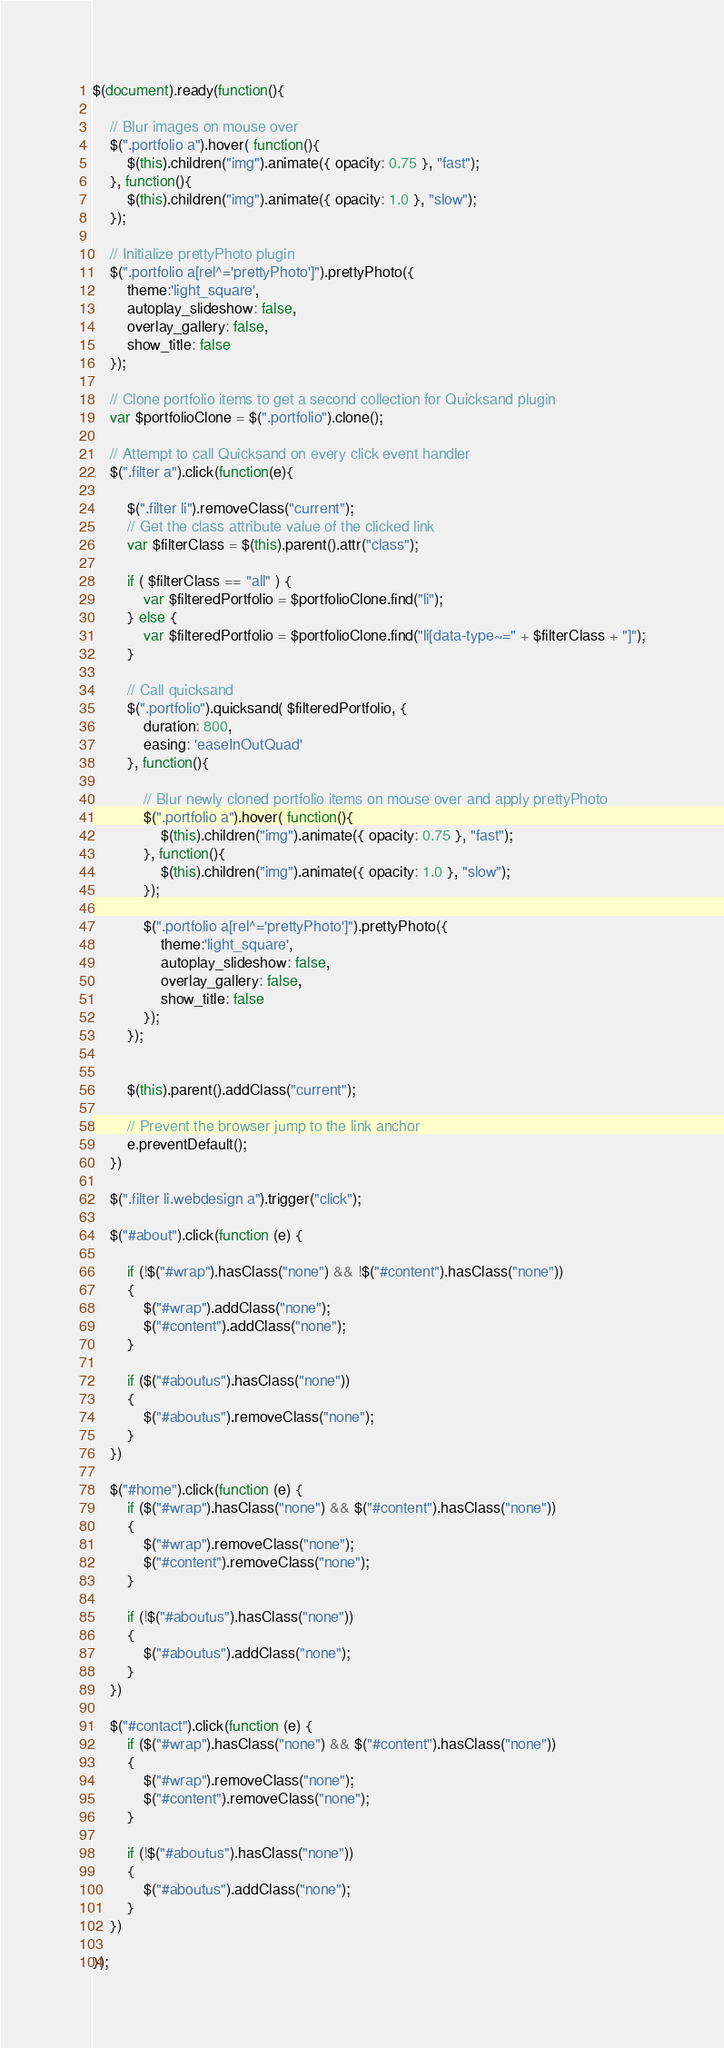<code> <loc_0><loc_0><loc_500><loc_500><_JavaScript_>$(document).ready(function(){

	// Blur images on mouse over
	$(".portfolio a").hover( function(){ 
		$(this).children("img").animate({ opacity: 0.75 }, "fast"); 
	}, function(){ 
		$(this).children("img").animate({ opacity: 1.0 }, "slow"); 
	}); 
	
	// Initialize prettyPhoto plugin
	$(".portfolio a[rel^='prettyPhoto']").prettyPhoto({
		theme:'light_square', 
		autoplay_slideshow: false, 
		overlay_gallery: false, 
		show_title: false
	});

	// Clone portfolio items to get a second collection for Quicksand plugin
	var $portfolioClone = $(".portfolio").clone();
	
	// Attempt to call Quicksand on every click event handler
	$(".filter a").click(function(e){
		
		$(".filter li").removeClass("current");	
		// Get the class attribute value of the clicked link
		var $filterClass = $(this).parent().attr("class");

		if ( $filterClass == "all" ) {
			var $filteredPortfolio = $portfolioClone.find("li");
		} else {
			var $filteredPortfolio = $portfolioClone.find("li[data-type~=" + $filterClass + "]");
		}
		
		// Call quicksand
		$(".portfolio").quicksand( $filteredPortfolio, { 
			duration: 800, 
			easing: 'easeInOutQuad' 
		}, function(){
			
			// Blur newly cloned portfolio items on mouse over and apply prettyPhoto
			$(".portfolio a").hover( function(){ 
				$(this).children("img").animate({ opacity: 0.75 }, "fast"); 
			}, function(){ 
				$(this).children("img").animate({ opacity: 1.0 }, "slow"); 
			}); 
			
			$(".portfolio a[rel^='prettyPhoto']").prettyPhoto({
				theme:'light_square', 
				autoplay_slideshow: false, 
				overlay_gallery: false, 
				show_title: false
			});
		});


		$(this).parent().addClass("current");

		// Prevent the browser jump to the link anchor
		e.preventDefault();
	})

	$(".filter li.webdesign a").trigger("click");

	$("#about").click(function (e) {

		if (!$("#wrap").hasClass("none") && !$("#content").hasClass("none"))
		{
			$("#wrap").addClass("none");
			$("#content").addClass("none");
		}

		if ($("#aboutus").hasClass("none"))
		{
			$("#aboutus").removeClass("none");
		}
	})

	$("#home").click(function (e) {
		if ($("#wrap").hasClass("none") && $("#content").hasClass("none"))
		{
			$("#wrap").removeClass("none");
			$("#content").removeClass("none");
		}

		if (!$("#aboutus").hasClass("none"))
		{
			$("#aboutus").addClass("none");
		}
	})

	$("#contact").click(function (e) {
		if ($("#wrap").hasClass("none") && $("#content").hasClass("none"))
		{
			$("#wrap").removeClass("none");
			$("#content").removeClass("none");
		}

		if (!$("#aboutus").hasClass("none"))
		{
			$("#aboutus").addClass("none");
		}
	})

});</code> 